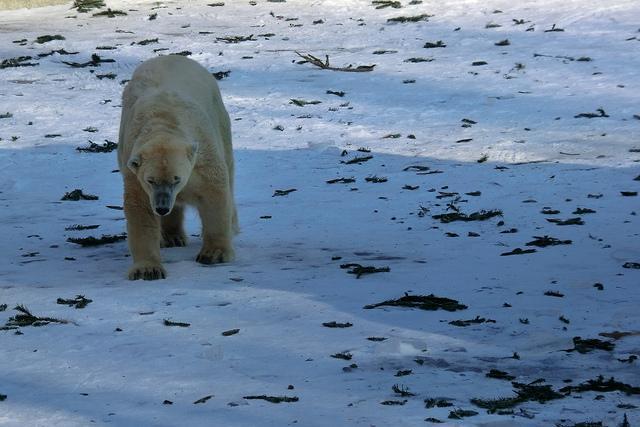How many animals are shown?
Give a very brief answer. 1. 